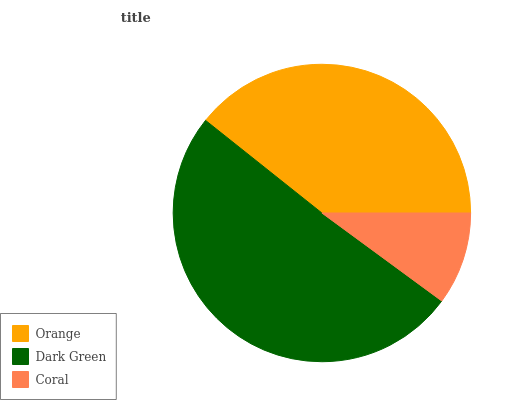Is Coral the minimum?
Answer yes or no. Yes. Is Dark Green the maximum?
Answer yes or no. Yes. Is Dark Green the minimum?
Answer yes or no. No. Is Coral the maximum?
Answer yes or no. No. Is Dark Green greater than Coral?
Answer yes or no. Yes. Is Coral less than Dark Green?
Answer yes or no. Yes. Is Coral greater than Dark Green?
Answer yes or no. No. Is Dark Green less than Coral?
Answer yes or no. No. Is Orange the high median?
Answer yes or no. Yes. Is Orange the low median?
Answer yes or no. Yes. Is Dark Green the high median?
Answer yes or no. No. Is Dark Green the low median?
Answer yes or no. No. 